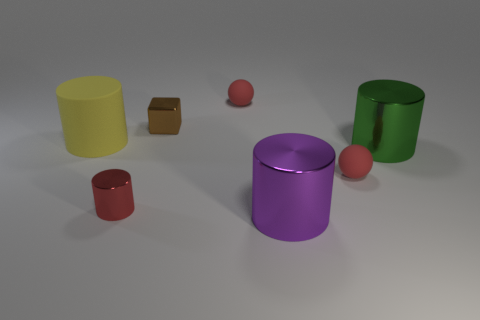Subtract all big green metal cylinders. How many cylinders are left? 3 Subtract 1 cylinders. How many cylinders are left? 3 Add 3 large cylinders. How many objects exist? 10 Subtract all red cylinders. How many cylinders are left? 3 Subtract all brown cylinders. Subtract all brown blocks. How many cylinders are left? 4 Subtract all cylinders. How many objects are left? 3 Subtract 0 purple blocks. How many objects are left? 7 Subtract all big purple cylinders. Subtract all yellow cylinders. How many objects are left? 5 Add 3 purple cylinders. How many purple cylinders are left? 4 Add 3 brown metallic blocks. How many brown metallic blocks exist? 4 